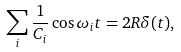Convert formula to latex. <formula><loc_0><loc_0><loc_500><loc_500>\sum _ { i } \frac { 1 } { C _ { i } } \cos \omega _ { i } t = 2 R \delta ( t ) ,</formula> 